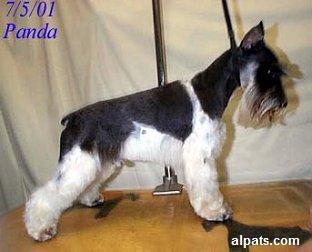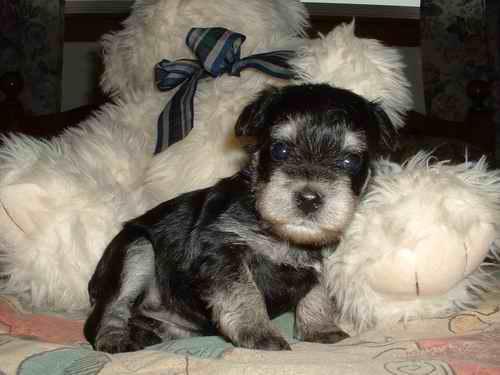The first image is the image on the left, the second image is the image on the right. Considering the images on both sides, is "a black and white dog is standing in the grass looking at the camera" valid? Answer yes or no. No. The first image is the image on the left, the second image is the image on the right. Analyze the images presented: Is the assertion "At least one dog is standing on grass." valid? Answer yes or no. No. 